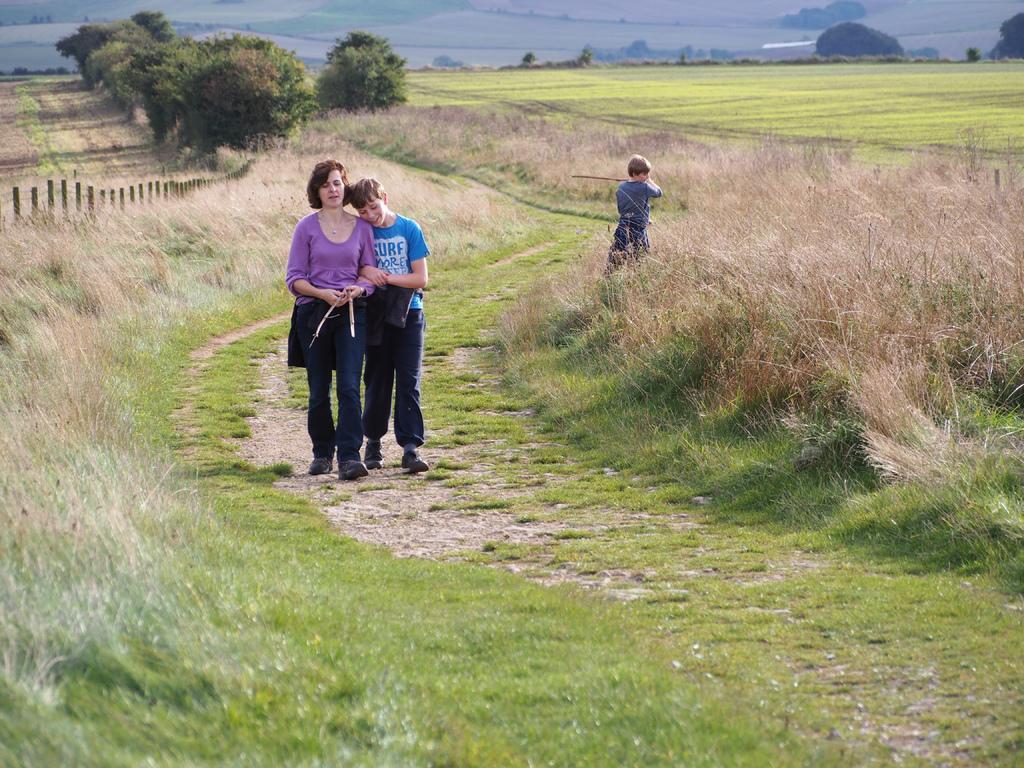How would you summarize this image in a sentence or two? In the picture we can see a grass surface on it, we can see some part of the path and on it we can see a woman and a boy standing together and some far away from them, we can see another boy standing in the grass and besides them we can see full of grass plants and in the background we can see trees, plants and crops. 